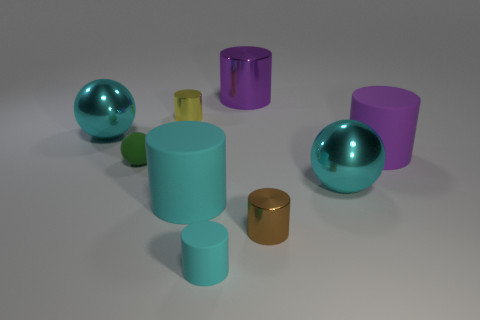What number of yellow cylinders are in front of the cyan cylinder in front of the small brown metal object to the right of the small cyan rubber thing?
Your answer should be very brief. 0. There is a purple object to the right of the small brown metallic thing; how big is it?
Offer a very short reply. Large. How many green matte balls are the same size as the yellow thing?
Your answer should be compact. 1. There is a purple shiny cylinder; does it have the same size as the cyan shiny thing that is behind the big purple rubber cylinder?
Your response must be concise. Yes. What number of things are yellow cylinders or tiny matte cylinders?
Give a very brief answer. 2. How many matte cylinders are the same color as the small sphere?
Ensure brevity in your answer.  0. There is a green matte thing that is the same size as the yellow shiny cylinder; what shape is it?
Your answer should be very brief. Sphere. Is there a tiny brown object of the same shape as the purple rubber thing?
Your answer should be very brief. Yes. How many cyan spheres are the same material as the brown cylinder?
Ensure brevity in your answer.  2. Does the cylinder that is in front of the tiny brown shiny cylinder have the same material as the tiny brown cylinder?
Offer a terse response. No. 